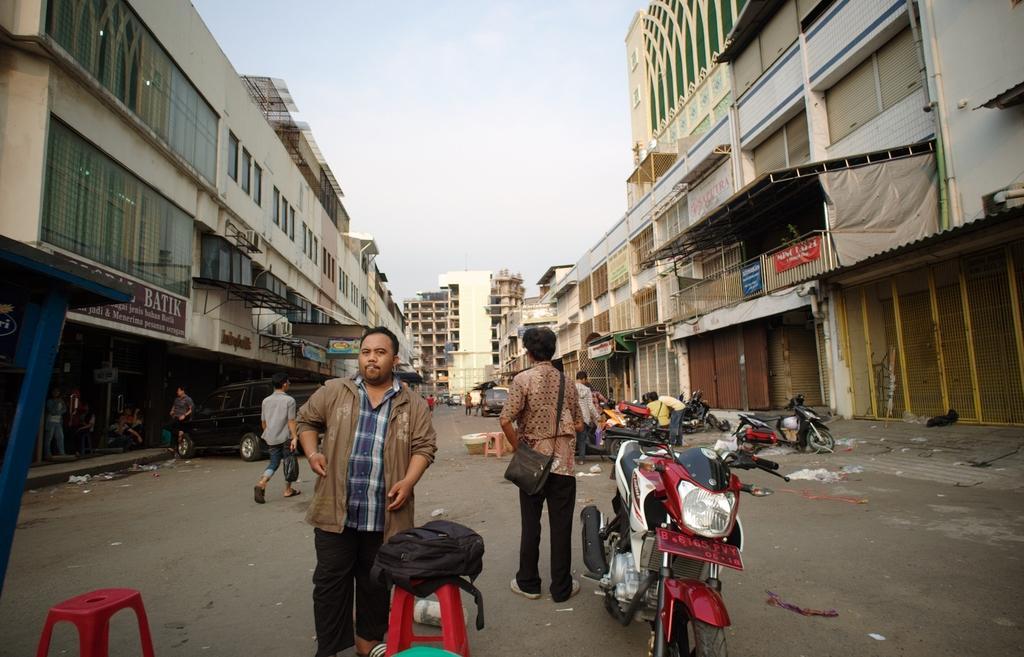Can you describe this image briefly? In this picture we can see people, vehicles, stools and some objects on the ground and in the background we can see buildings and the sky. 